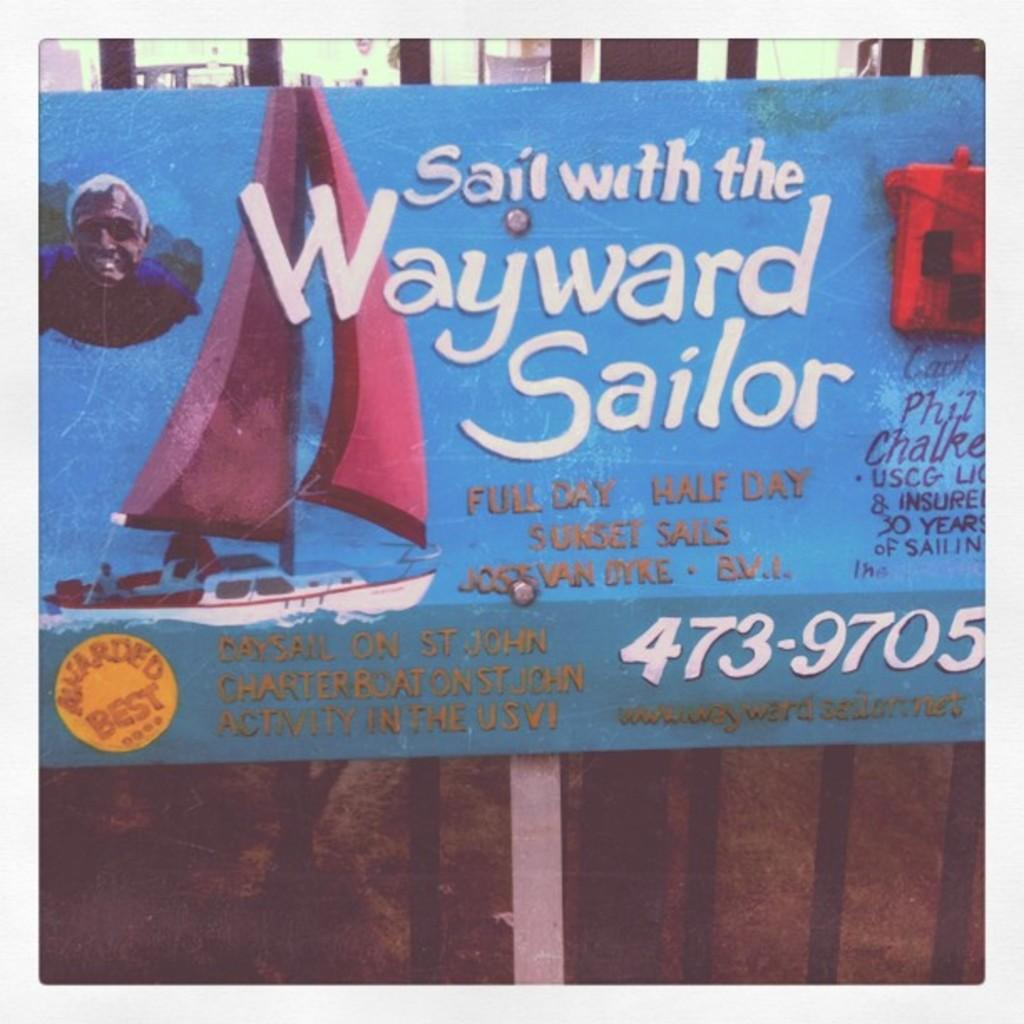What is the main subject in the center of the image? There is a placard in the center of the image. What can be seen on the placard? The placard has some text on it. How many lizards can be seen climbing on the house in the image? There are no lizards present in the image. What type of songs can be heard playing in the background of the image? There is no mention of songs or any audio element in the image. 